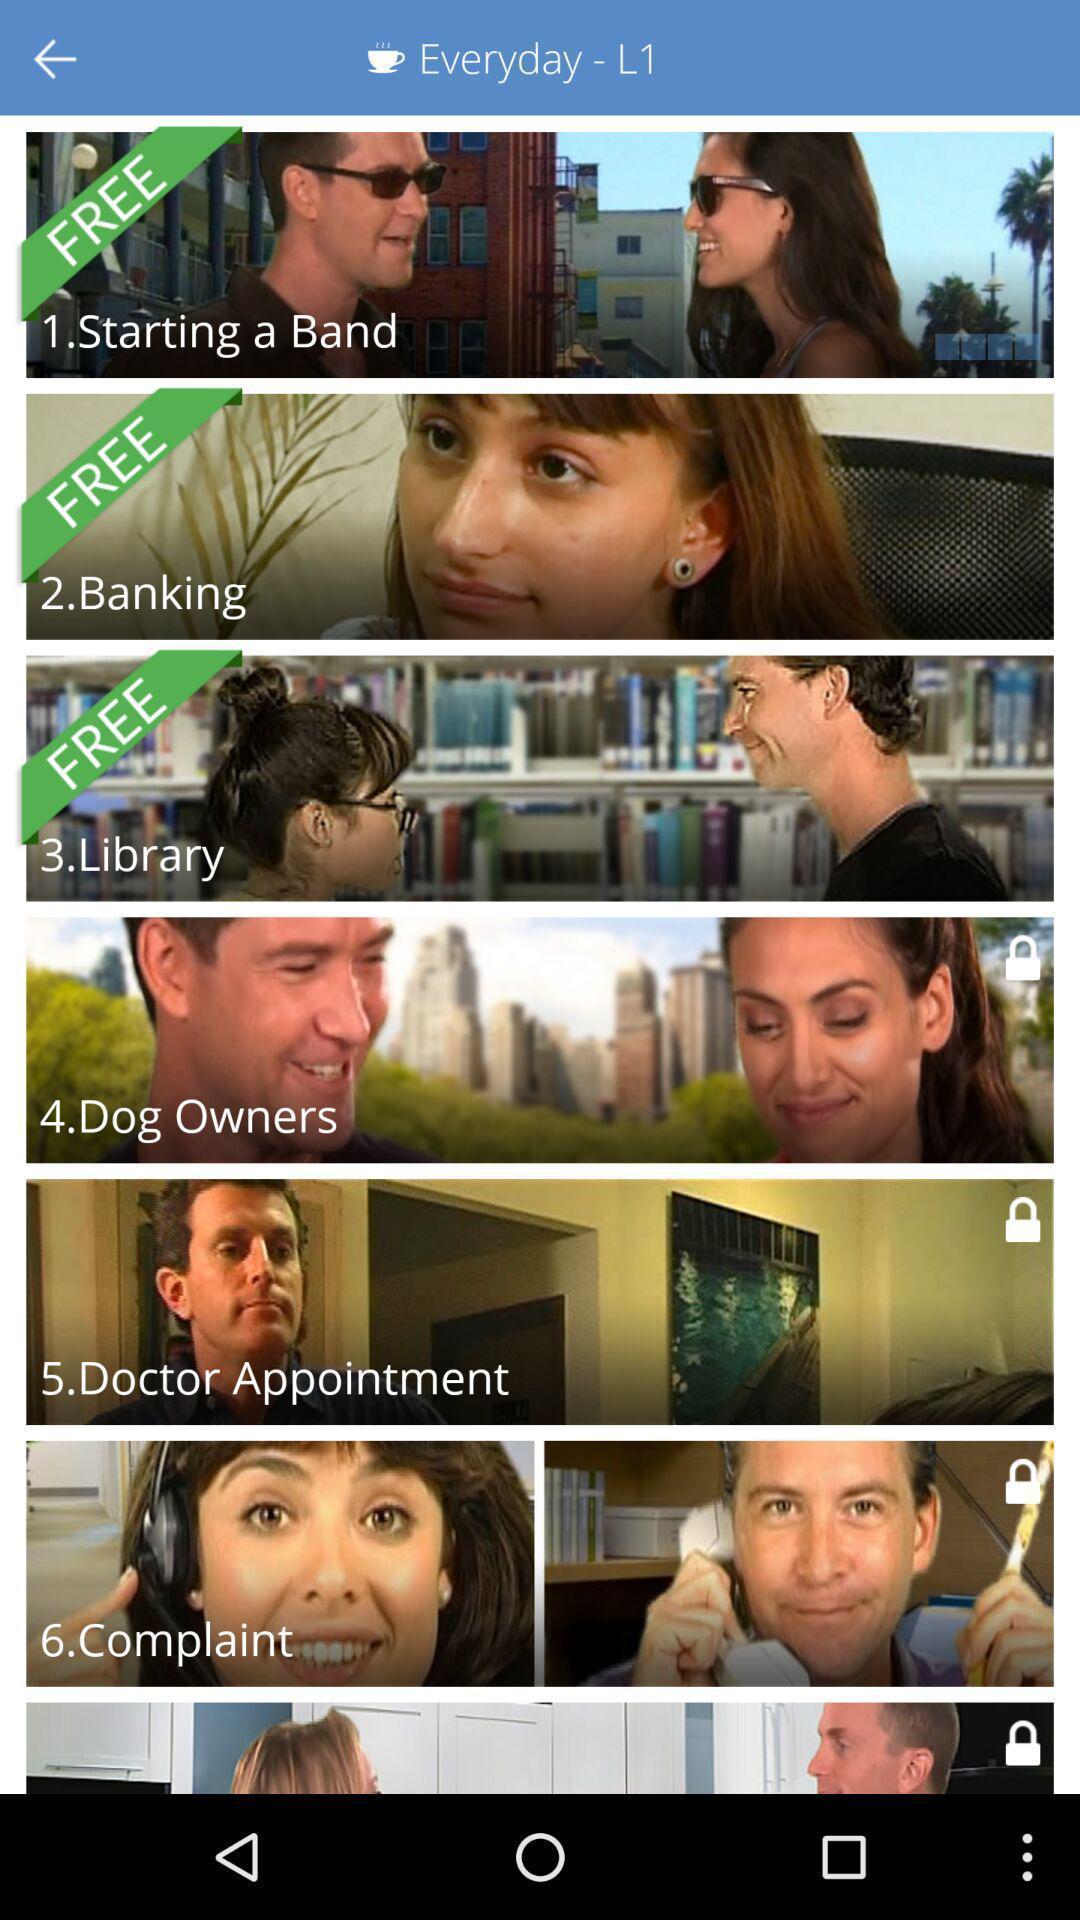Describe the key features of this screenshot. Screen displaying multiple topics in a language learning application. 